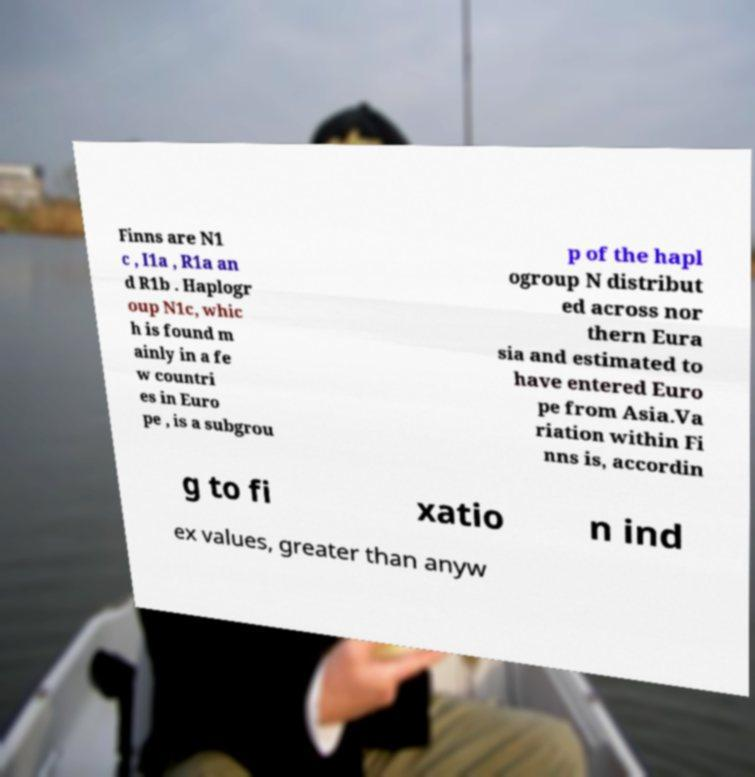For documentation purposes, I need the text within this image transcribed. Could you provide that? Finns are N1 c , I1a , R1a an d R1b . Haplogr oup N1c, whic h is found m ainly in a fe w countri es in Euro pe , is a subgrou p of the hapl ogroup N distribut ed across nor thern Eura sia and estimated to have entered Euro pe from Asia.Va riation within Fi nns is, accordin g to fi xatio n ind ex values, greater than anyw 